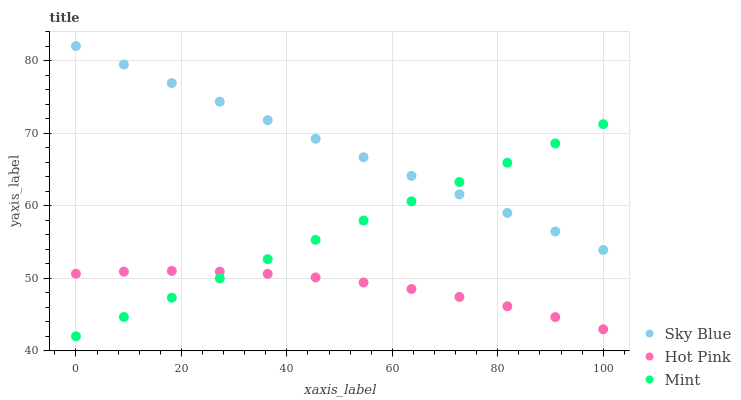Does Hot Pink have the minimum area under the curve?
Answer yes or no. Yes. Does Sky Blue have the maximum area under the curve?
Answer yes or no. Yes. Does Mint have the minimum area under the curve?
Answer yes or no. No. Does Mint have the maximum area under the curve?
Answer yes or no. No. Is Sky Blue the smoothest?
Answer yes or no. Yes. Is Hot Pink the roughest?
Answer yes or no. Yes. Is Mint the smoothest?
Answer yes or no. No. Is Mint the roughest?
Answer yes or no. No. Does Mint have the lowest value?
Answer yes or no. Yes. Does Hot Pink have the lowest value?
Answer yes or no. No. Does Sky Blue have the highest value?
Answer yes or no. Yes. Does Mint have the highest value?
Answer yes or no. No. Is Hot Pink less than Sky Blue?
Answer yes or no. Yes. Is Sky Blue greater than Hot Pink?
Answer yes or no. Yes. Does Hot Pink intersect Mint?
Answer yes or no. Yes. Is Hot Pink less than Mint?
Answer yes or no. No. Is Hot Pink greater than Mint?
Answer yes or no. No. Does Hot Pink intersect Sky Blue?
Answer yes or no. No. 